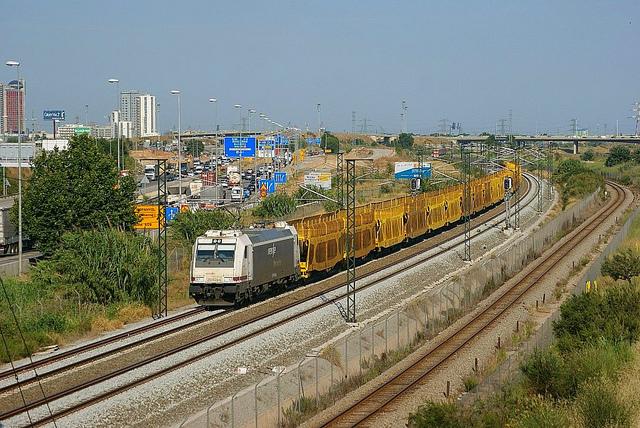Can you see the end of the train?
Concise answer only. No. How many train tracks?
Answer briefly. 3. On what side of the train are the empty train tracks located?
Keep it brief. Right. Is there a road next to the train tracks?
Concise answer only. Yes. Does the train look like its turning in certain direction?
Short answer required. No. What is the train carrying?
Answer briefly. Cargo. 